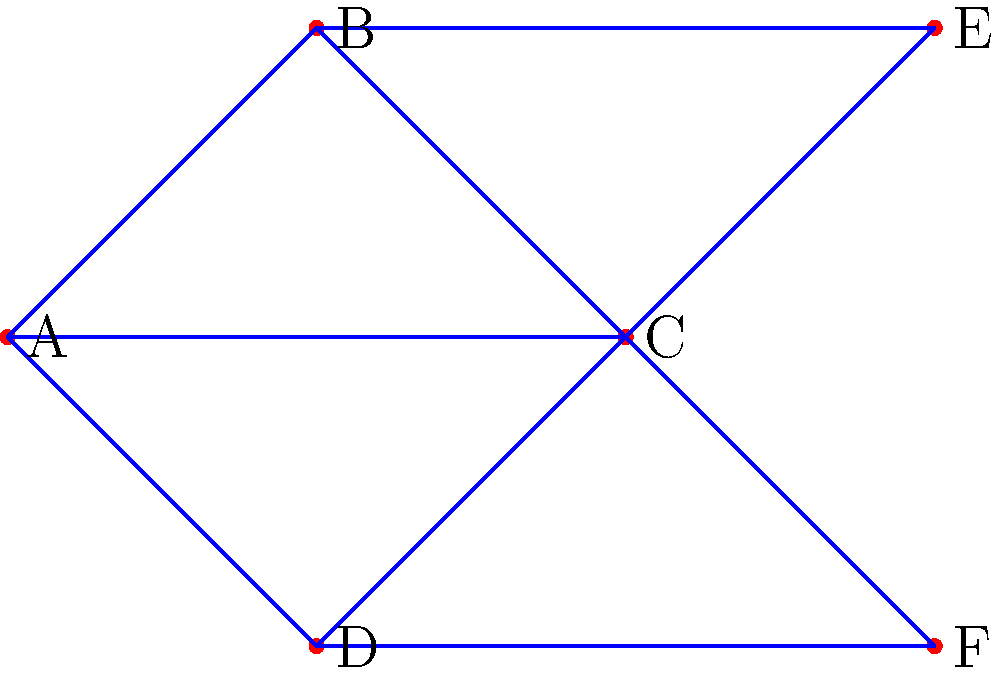Given the network topology shown above, where each edge has a cost of 1 and a bandwidth capacity of 10 units, design an optimal routing scheme to maximize the total flow from node A to node F, subject to the constraint that no more than 15 units of flow can pass through node C. What is the maximum achievable flow? To solve this problem, we'll use the principles of network flow optimization and the Ford-Fulkerson algorithm, with modifications to account for the node capacity constraint:

1. Identify all possible paths from A to F:
   Path 1: A -> B -> E -> C -> F
   Path 2: A -> C -> F
   Path 3: A -> D -> C -> F
   Path 4: A -> B -> C -> F
   Path 5: A -> C -> E -> B -> C -> F (inefficient, can be ignored)

2. Consider the constraint on node C (max 15 units):
   This limits the total flow through paths involving C.

3. Maximize flow through paths not involving C first:
   Path 1: A -> B -> E -> C -> F can carry 10 units

4. Distribute remaining flow through C:
   5 units remain for paths involving C
   Optimal distribution:
   Path 2: A -> C -> F: 5 units
   Path 3 and 4 are not used as they don't increase the total flow

5. Calculate total flow:
   10 units (Path 1) + 5 units (Path 2) = 15 units

6. Verify constraints:
   - Edge capacity (10 units) is respected on all edges
   - Node C constraint (15 units) is met: 10 units from Path 1 + 5 units from Path 2

Therefore, the maximum achievable flow from A to F, given the constraints, is 15 units.
Answer: 15 units 